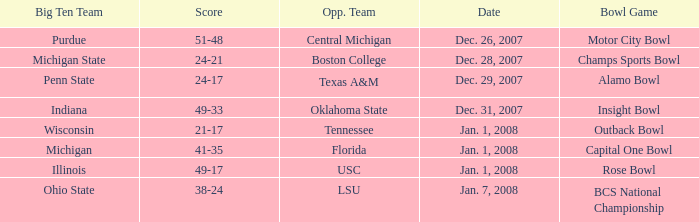Who was Purdue's opponent? Central Michigan. 